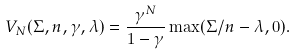<formula> <loc_0><loc_0><loc_500><loc_500>V _ { N } ( \Sigma , n , \gamma , \lambda ) = \frac { \gamma ^ { N } } { 1 - \gamma } \max ( \Sigma / n - \lambda , 0 ) .</formula> 